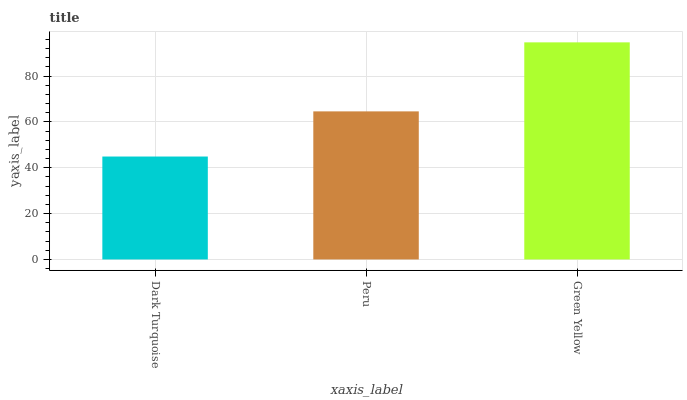Is Dark Turquoise the minimum?
Answer yes or no. Yes. Is Green Yellow the maximum?
Answer yes or no. Yes. Is Peru the minimum?
Answer yes or no. No. Is Peru the maximum?
Answer yes or no. No. Is Peru greater than Dark Turquoise?
Answer yes or no. Yes. Is Dark Turquoise less than Peru?
Answer yes or no. Yes. Is Dark Turquoise greater than Peru?
Answer yes or no. No. Is Peru less than Dark Turquoise?
Answer yes or no. No. Is Peru the high median?
Answer yes or no. Yes. Is Peru the low median?
Answer yes or no. Yes. Is Dark Turquoise the high median?
Answer yes or no. No. Is Green Yellow the low median?
Answer yes or no. No. 